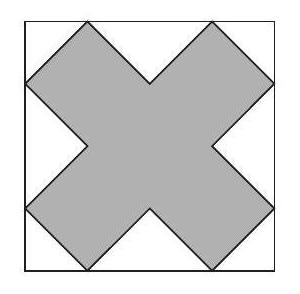What geometric properties can be derived from this composition? The geometric composition allows analysis of properties such as symmetry, area ratios between the cross-shape and the square, and the angles involved. Specifically, the cross-shape is symmetrical about both diagonals of the square, and the area comparison can lead to interesting discussions on space efficiency in geometric designs. Could this arrangement have practical applications in design or architecture? Absolutely! This type of geometric arrangement is useful in architectural designs where space utilization is crucial. It could influence patterns in tiling, mosaics, or even structural elements where stress distribution might benefit from such symmetrical designs. 